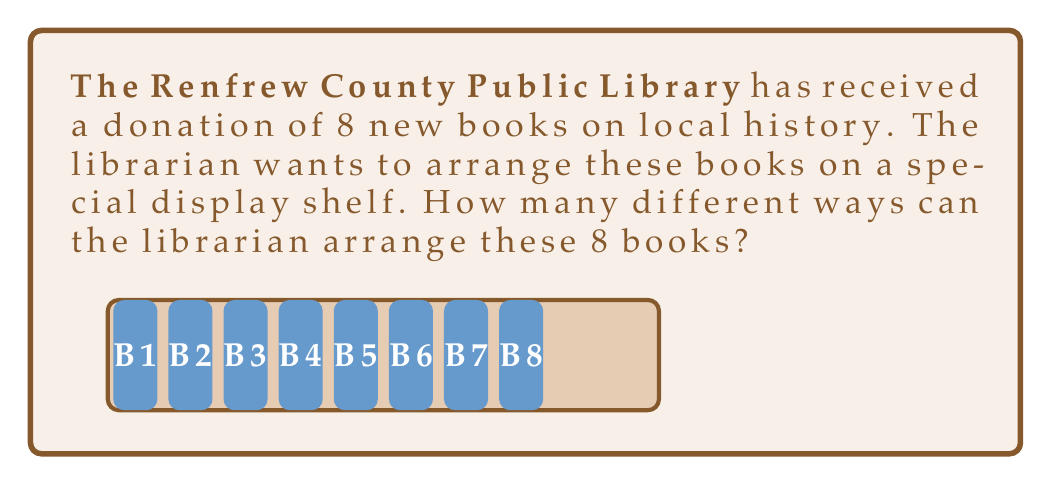Show me your answer to this math problem. Let's approach this step-by-step:

1) This is a permutation problem. We need to determine the number of ways to arrange 8 distinct objects (books) in a line.

2) For the first position, we have 8 choices of books to place.

3) After placing the first book, we have 7 books left for the second position.

4) For the third position, we'll have 6 choices, and so on.

5) This continues until we place the last book, for which we'll have only 1 choice.

6) The total number of arrangements is the product of all these choices:

   $$ 8 \times 7 \times 6 \times 5 \times 4 \times 3 \times 2 \times 1 $$

7) This product is known as 8 factorial, written as 8!

8) We can calculate this:
   $$ 8! = 8 \times 7 \times 6 \times 5 \times 4 \times 3 \times 2 \times 1 = 40,320 $$

Therefore, there are 40,320 different ways to arrange the 8 books on the shelf.
Answer: 40,320 